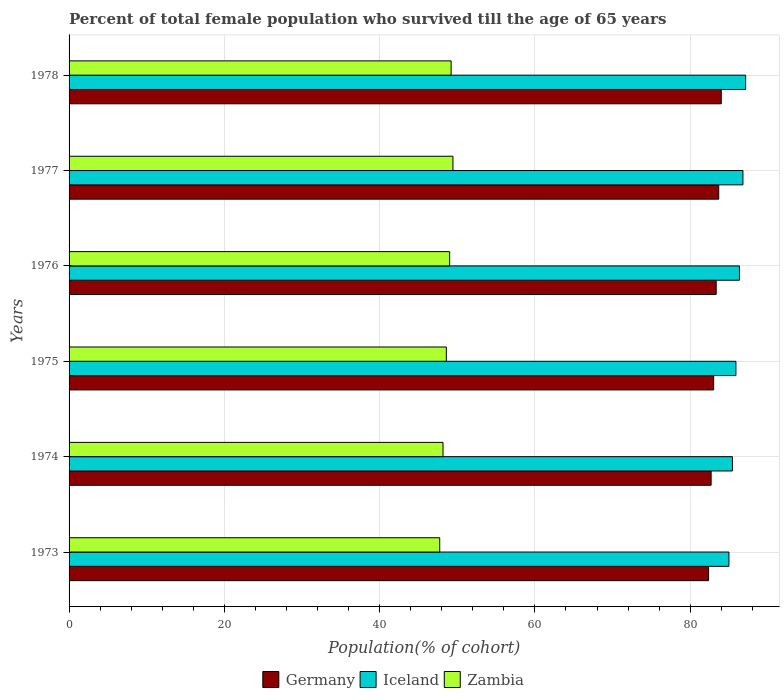How many groups of bars are there?
Offer a very short reply. 6. Are the number of bars per tick equal to the number of legend labels?
Your answer should be compact. Yes. How many bars are there on the 5th tick from the top?
Offer a terse response. 3. What is the label of the 2nd group of bars from the top?
Provide a succinct answer. 1977. What is the percentage of total female population who survived till the age of 65 years in Germany in 1978?
Your answer should be compact. 84. Across all years, what is the maximum percentage of total female population who survived till the age of 65 years in Germany?
Give a very brief answer. 84. Across all years, what is the minimum percentage of total female population who survived till the age of 65 years in Iceland?
Your response must be concise. 84.99. In which year was the percentage of total female population who survived till the age of 65 years in Germany maximum?
Provide a short and direct response. 1978. In which year was the percentage of total female population who survived till the age of 65 years in Germany minimum?
Your response must be concise. 1973. What is the total percentage of total female population who survived till the age of 65 years in Germany in the graph?
Make the answer very short. 499.11. What is the difference between the percentage of total female population who survived till the age of 65 years in Zambia in 1973 and that in 1974?
Provide a succinct answer. -0.43. What is the difference between the percentage of total female population who survived till the age of 65 years in Iceland in 1978 and the percentage of total female population who survived till the age of 65 years in Zambia in 1977?
Ensure brevity in your answer.  37.7. What is the average percentage of total female population who survived till the age of 65 years in Germany per year?
Keep it short and to the point. 83.19. In the year 1974, what is the difference between the percentage of total female population who survived till the age of 65 years in Zambia and percentage of total female population who survived till the age of 65 years in Germany?
Ensure brevity in your answer.  -34.53. In how many years, is the percentage of total female population who survived till the age of 65 years in Iceland greater than 76 %?
Your answer should be very brief. 6. What is the ratio of the percentage of total female population who survived till the age of 65 years in Zambia in 1975 to that in 1976?
Provide a short and direct response. 0.99. Is the percentage of total female population who survived till the age of 65 years in Iceland in 1973 less than that in 1976?
Offer a terse response. Yes. Is the difference between the percentage of total female population who survived till the age of 65 years in Zambia in 1974 and 1978 greater than the difference between the percentage of total female population who survived till the age of 65 years in Germany in 1974 and 1978?
Offer a very short reply. Yes. What is the difference between the highest and the second highest percentage of total female population who survived till the age of 65 years in Zambia?
Your answer should be compact. 0.23. What is the difference between the highest and the lowest percentage of total female population who survived till the age of 65 years in Zambia?
Give a very brief answer. 1.7. In how many years, is the percentage of total female population who survived till the age of 65 years in Germany greater than the average percentage of total female population who survived till the age of 65 years in Germany taken over all years?
Your answer should be very brief. 3. Is the sum of the percentage of total female population who survived till the age of 65 years in Iceland in 1976 and 1978 greater than the maximum percentage of total female population who survived till the age of 65 years in Germany across all years?
Provide a short and direct response. Yes. What does the 2nd bar from the bottom in 1976 represents?
Provide a short and direct response. Iceland. Are the values on the major ticks of X-axis written in scientific E-notation?
Ensure brevity in your answer.  No. Does the graph contain any zero values?
Keep it short and to the point. No. Does the graph contain grids?
Your response must be concise. Yes. Where does the legend appear in the graph?
Your answer should be compact. Bottom center. How many legend labels are there?
Give a very brief answer. 3. How are the legend labels stacked?
Offer a very short reply. Horizontal. What is the title of the graph?
Make the answer very short. Percent of total female population who survived till the age of 65 years. Does "Bhutan" appear as one of the legend labels in the graph?
Ensure brevity in your answer.  No. What is the label or title of the X-axis?
Make the answer very short. Population(% of cohort). What is the Population(% of cohort) of Germany in 1973?
Ensure brevity in your answer.  82.37. What is the Population(% of cohort) in Iceland in 1973?
Keep it short and to the point. 84.99. What is the Population(% of cohort) of Zambia in 1973?
Your answer should be very brief. 47.74. What is the Population(% of cohort) in Germany in 1974?
Your answer should be compact. 82.7. What is the Population(% of cohort) in Iceland in 1974?
Make the answer very short. 85.44. What is the Population(% of cohort) of Zambia in 1974?
Ensure brevity in your answer.  48.17. What is the Population(% of cohort) of Germany in 1975?
Give a very brief answer. 83.02. What is the Population(% of cohort) of Iceland in 1975?
Give a very brief answer. 85.89. What is the Population(% of cohort) of Zambia in 1975?
Your answer should be compact. 48.59. What is the Population(% of cohort) in Germany in 1976?
Give a very brief answer. 83.35. What is the Population(% of cohort) of Iceland in 1976?
Your response must be concise. 86.34. What is the Population(% of cohort) in Zambia in 1976?
Give a very brief answer. 49.02. What is the Population(% of cohort) of Germany in 1977?
Your answer should be very brief. 83.67. What is the Population(% of cohort) in Iceland in 1977?
Make the answer very short. 86.79. What is the Population(% of cohort) in Zambia in 1977?
Keep it short and to the point. 49.44. What is the Population(% of cohort) of Germany in 1978?
Make the answer very short. 84. What is the Population(% of cohort) in Iceland in 1978?
Provide a succinct answer. 87.15. What is the Population(% of cohort) in Zambia in 1978?
Provide a succinct answer. 49.21. Across all years, what is the maximum Population(% of cohort) in Germany?
Offer a very short reply. 84. Across all years, what is the maximum Population(% of cohort) in Iceland?
Your response must be concise. 87.15. Across all years, what is the maximum Population(% of cohort) in Zambia?
Give a very brief answer. 49.44. Across all years, what is the minimum Population(% of cohort) of Germany?
Offer a terse response. 82.37. Across all years, what is the minimum Population(% of cohort) of Iceland?
Your response must be concise. 84.99. Across all years, what is the minimum Population(% of cohort) of Zambia?
Offer a very short reply. 47.74. What is the total Population(% of cohort) of Germany in the graph?
Ensure brevity in your answer.  499.11. What is the total Population(% of cohort) of Iceland in the graph?
Your answer should be very brief. 516.6. What is the total Population(% of cohort) in Zambia in the graph?
Offer a terse response. 292.16. What is the difference between the Population(% of cohort) of Germany in 1973 and that in 1974?
Ensure brevity in your answer.  -0.33. What is the difference between the Population(% of cohort) in Iceland in 1973 and that in 1974?
Your response must be concise. -0.45. What is the difference between the Population(% of cohort) in Zambia in 1973 and that in 1974?
Provide a succinct answer. -0.43. What is the difference between the Population(% of cohort) in Germany in 1973 and that in 1975?
Provide a succinct answer. -0.65. What is the difference between the Population(% of cohort) in Iceland in 1973 and that in 1975?
Provide a succinct answer. -0.9. What is the difference between the Population(% of cohort) of Zambia in 1973 and that in 1975?
Your answer should be compact. -0.85. What is the difference between the Population(% of cohort) in Germany in 1973 and that in 1976?
Your answer should be compact. -0.98. What is the difference between the Population(% of cohort) in Iceland in 1973 and that in 1976?
Your response must be concise. -1.35. What is the difference between the Population(% of cohort) in Zambia in 1973 and that in 1976?
Keep it short and to the point. -1.28. What is the difference between the Population(% of cohort) of Germany in 1973 and that in 1977?
Offer a terse response. -1.3. What is the difference between the Population(% of cohort) of Iceland in 1973 and that in 1977?
Provide a succinct answer. -1.8. What is the difference between the Population(% of cohort) of Zambia in 1973 and that in 1977?
Make the answer very short. -1.7. What is the difference between the Population(% of cohort) of Germany in 1973 and that in 1978?
Provide a succinct answer. -1.63. What is the difference between the Population(% of cohort) of Iceland in 1973 and that in 1978?
Provide a short and direct response. -2.16. What is the difference between the Population(% of cohort) in Zambia in 1973 and that in 1978?
Keep it short and to the point. -1.47. What is the difference between the Population(% of cohort) of Germany in 1974 and that in 1975?
Your answer should be very brief. -0.33. What is the difference between the Population(% of cohort) of Iceland in 1974 and that in 1975?
Provide a succinct answer. -0.45. What is the difference between the Population(% of cohort) in Zambia in 1974 and that in 1975?
Ensure brevity in your answer.  -0.43. What is the difference between the Population(% of cohort) of Germany in 1974 and that in 1976?
Your answer should be very brief. -0.65. What is the difference between the Population(% of cohort) of Iceland in 1974 and that in 1976?
Your answer should be compact. -0.9. What is the difference between the Population(% of cohort) in Zambia in 1974 and that in 1976?
Provide a succinct answer. -0.85. What is the difference between the Population(% of cohort) of Germany in 1974 and that in 1977?
Your answer should be very brief. -0.98. What is the difference between the Population(% of cohort) of Iceland in 1974 and that in 1977?
Your answer should be very brief. -1.35. What is the difference between the Population(% of cohort) in Zambia in 1974 and that in 1977?
Your response must be concise. -1.28. What is the difference between the Population(% of cohort) of Germany in 1974 and that in 1978?
Give a very brief answer. -1.31. What is the difference between the Population(% of cohort) in Iceland in 1974 and that in 1978?
Your response must be concise. -1.71. What is the difference between the Population(% of cohort) of Zambia in 1974 and that in 1978?
Your answer should be compact. -1.04. What is the difference between the Population(% of cohort) in Germany in 1975 and that in 1976?
Your response must be concise. -0.33. What is the difference between the Population(% of cohort) of Iceland in 1975 and that in 1976?
Provide a succinct answer. -0.45. What is the difference between the Population(% of cohort) in Zambia in 1975 and that in 1976?
Offer a very short reply. -0.43. What is the difference between the Population(% of cohort) in Germany in 1975 and that in 1977?
Your answer should be very brief. -0.65. What is the difference between the Population(% of cohort) of Iceland in 1975 and that in 1977?
Your response must be concise. -0.9. What is the difference between the Population(% of cohort) of Zambia in 1975 and that in 1977?
Ensure brevity in your answer.  -0.85. What is the difference between the Population(% of cohort) in Germany in 1975 and that in 1978?
Give a very brief answer. -0.98. What is the difference between the Population(% of cohort) of Iceland in 1975 and that in 1978?
Your answer should be very brief. -1.25. What is the difference between the Population(% of cohort) in Zambia in 1975 and that in 1978?
Offer a very short reply. -0.62. What is the difference between the Population(% of cohort) of Germany in 1976 and that in 1977?
Offer a terse response. -0.33. What is the difference between the Population(% of cohort) in Iceland in 1976 and that in 1977?
Your answer should be very brief. -0.45. What is the difference between the Population(% of cohort) of Zambia in 1976 and that in 1977?
Give a very brief answer. -0.43. What is the difference between the Population(% of cohort) of Germany in 1976 and that in 1978?
Provide a succinct answer. -0.65. What is the difference between the Population(% of cohort) of Iceland in 1976 and that in 1978?
Your response must be concise. -0.8. What is the difference between the Population(% of cohort) in Zambia in 1976 and that in 1978?
Give a very brief answer. -0.19. What is the difference between the Population(% of cohort) in Germany in 1977 and that in 1978?
Your response must be concise. -0.33. What is the difference between the Population(% of cohort) in Iceland in 1977 and that in 1978?
Your answer should be compact. -0.35. What is the difference between the Population(% of cohort) in Zambia in 1977 and that in 1978?
Your answer should be compact. 0.23. What is the difference between the Population(% of cohort) of Germany in 1973 and the Population(% of cohort) of Iceland in 1974?
Offer a very short reply. -3.07. What is the difference between the Population(% of cohort) in Germany in 1973 and the Population(% of cohort) in Zambia in 1974?
Offer a terse response. 34.2. What is the difference between the Population(% of cohort) in Iceland in 1973 and the Population(% of cohort) in Zambia in 1974?
Offer a very short reply. 36.82. What is the difference between the Population(% of cohort) of Germany in 1973 and the Population(% of cohort) of Iceland in 1975?
Offer a terse response. -3.52. What is the difference between the Population(% of cohort) of Germany in 1973 and the Population(% of cohort) of Zambia in 1975?
Provide a succinct answer. 33.78. What is the difference between the Population(% of cohort) of Iceland in 1973 and the Population(% of cohort) of Zambia in 1975?
Offer a terse response. 36.4. What is the difference between the Population(% of cohort) in Germany in 1973 and the Population(% of cohort) in Iceland in 1976?
Provide a succinct answer. -3.97. What is the difference between the Population(% of cohort) in Germany in 1973 and the Population(% of cohort) in Zambia in 1976?
Offer a terse response. 33.35. What is the difference between the Population(% of cohort) in Iceland in 1973 and the Population(% of cohort) in Zambia in 1976?
Give a very brief answer. 35.97. What is the difference between the Population(% of cohort) of Germany in 1973 and the Population(% of cohort) of Iceland in 1977?
Provide a short and direct response. -4.42. What is the difference between the Population(% of cohort) of Germany in 1973 and the Population(% of cohort) of Zambia in 1977?
Ensure brevity in your answer.  32.93. What is the difference between the Population(% of cohort) of Iceland in 1973 and the Population(% of cohort) of Zambia in 1977?
Provide a succinct answer. 35.55. What is the difference between the Population(% of cohort) in Germany in 1973 and the Population(% of cohort) in Iceland in 1978?
Your response must be concise. -4.78. What is the difference between the Population(% of cohort) in Germany in 1973 and the Population(% of cohort) in Zambia in 1978?
Provide a short and direct response. 33.16. What is the difference between the Population(% of cohort) of Iceland in 1973 and the Population(% of cohort) of Zambia in 1978?
Ensure brevity in your answer.  35.78. What is the difference between the Population(% of cohort) in Germany in 1974 and the Population(% of cohort) in Iceland in 1975?
Make the answer very short. -3.2. What is the difference between the Population(% of cohort) of Germany in 1974 and the Population(% of cohort) of Zambia in 1975?
Your answer should be compact. 34.11. What is the difference between the Population(% of cohort) in Iceland in 1974 and the Population(% of cohort) in Zambia in 1975?
Provide a succinct answer. 36.85. What is the difference between the Population(% of cohort) of Germany in 1974 and the Population(% of cohort) of Iceland in 1976?
Ensure brevity in your answer.  -3.65. What is the difference between the Population(% of cohort) of Germany in 1974 and the Population(% of cohort) of Zambia in 1976?
Offer a very short reply. 33.68. What is the difference between the Population(% of cohort) in Iceland in 1974 and the Population(% of cohort) in Zambia in 1976?
Offer a terse response. 36.42. What is the difference between the Population(% of cohort) of Germany in 1974 and the Population(% of cohort) of Iceland in 1977?
Ensure brevity in your answer.  -4.1. What is the difference between the Population(% of cohort) in Germany in 1974 and the Population(% of cohort) in Zambia in 1977?
Provide a short and direct response. 33.25. What is the difference between the Population(% of cohort) of Iceland in 1974 and the Population(% of cohort) of Zambia in 1977?
Offer a terse response. 36. What is the difference between the Population(% of cohort) in Germany in 1974 and the Population(% of cohort) in Iceland in 1978?
Offer a very short reply. -4.45. What is the difference between the Population(% of cohort) of Germany in 1974 and the Population(% of cohort) of Zambia in 1978?
Keep it short and to the point. 33.49. What is the difference between the Population(% of cohort) of Iceland in 1974 and the Population(% of cohort) of Zambia in 1978?
Your answer should be compact. 36.23. What is the difference between the Population(% of cohort) of Germany in 1975 and the Population(% of cohort) of Iceland in 1976?
Your answer should be very brief. -3.32. What is the difference between the Population(% of cohort) in Germany in 1975 and the Population(% of cohort) in Zambia in 1976?
Make the answer very short. 34.01. What is the difference between the Population(% of cohort) in Iceland in 1975 and the Population(% of cohort) in Zambia in 1976?
Make the answer very short. 36.87. What is the difference between the Population(% of cohort) in Germany in 1975 and the Population(% of cohort) in Iceland in 1977?
Make the answer very short. -3.77. What is the difference between the Population(% of cohort) in Germany in 1975 and the Population(% of cohort) in Zambia in 1977?
Ensure brevity in your answer.  33.58. What is the difference between the Population(% of cohort) of Iceland in 1975 and the Population(% of cohort) of Zambia in 1977?
Your answer should be very brief. 36.45. What is the difference between the Population(% of cohort) in Germany in 1975 and the Population(% of cohort) in Iceland in 1978?
Your response must be concise. -4.12. What is the difference between the Population(% of cohort) in Germany in 1975 and the Population(% of cohort) in Zambia in 1978?
Ensure brevity in your answer.  33.81. What is the difference between the Population(% of cohort) of Iceland in 1975 and the Population(% of cohort) of Zambia in 1978?
Give a very brief answer. 36.68. What is the difference between the Population(% of cohort) in Germany in 1976 and the Population(% of cohort) in Iceland in 1977?
Your answer should be compact. -3.45. What is the difference between the Population(% of cohort) of Germany in 1976 and the Population(% of cohort) of Zambia in 1977?
Your answer should be compact. 33.91. What is the difference between the Population(% of cohort) of Iceland in 1976 and the Population(% of cohort) of Zambia in 1977?
Offer a terse response. 36.9. What is the difference between the Population(% of cohort) of Germany in 1976 and the Population(% of cohort) of Iceland in 1978?
Keep it short and to the point. -3.8. What is the difference between the Population(% of cohort) in Germany in 1976 and the Population(% of cohort) in Zambia in 1978?
Provide a succinct answer. 34.14. What is the difference between the Population(% of cohort) of Iceland in 1976 and the Population(% of cohort) of Zambia in 1978?
Provide a succinct answer. 37.13. What is the difference between the Population(% of cohort) of Germany in 1977 and the Population(% of cohort) of Iceland in 1978?
Your answer should be very brief. -3.47. What is the difference between the Population(% of cohort) of Germany in 1977 and the Population(% of cohort) of Zambia in 1978?
Offer a very short reply. 34.47. What is the difference between the Population(% of cohort) in Iceland in 1977 and the Population(% of cohort) in Zambia in 1978?
Offer a very short reply. 37.58. What is the average Population(% of cohort) of Germany per year?
Give a very brief answer. 83.19. What is the average Population(% of cohort) in Iceland per year?
Give a very brief answer. 86.1. What is the average Population(% of cohort) in Zambia per year?
Make the answer very short. 48.69. In the year 1973, what is the difference between the Population(% of cohort) in Germany and Population(% of cohort) in Iceland?
Your response must be concise. -2.62. In the year 1973, what is the difference between the Population(% of cohort) in Germany and Population(% of cohort) in Zambia?
Give a very brief answer. 34.63. In the year 1973, what is the difference between the Population(% of cohort) in Iceland and Population(% of cohort) in Zambia?
Ensure brevity in your answer.  37.25. In the year 1974, what is the difference between the Population(% of cohort) of Germany and Population(% of cohort) of Iceland?
Provide a short and direct response. -2.74. In the year 1974, what is the difference between the Population(% of cohort) in Germany and Population(% of cohort) in Zambia?
Make the answer very short. 34.53. In the year 1974, what is the difference between the Population(% of cohort) of Iceland and Population(% of cohort) of Zambia?
Make the answer very short. 37.28. In the year 1975, what is the difference between the Population(% of cohort) of Germany and Population(% of cohort) of Iceland?
Provide a short and direct response. -2.87. In the year 1975, what is the difference between the Population(% of cohort) of Germany and Population(% of cohort) of Zambia?
Keep it short and to the point. 34.43. In the year 1975, what is the difference between the Population(% of cohort) of Iceland and Population(% of cohort) of Zambia?
Your answer should be compact. 37.3. In the year 1976, what is the difference between the Population(% of cohort) in Germany and Population(% of cohort) in Iceland?
Offer a very short reply. -2.99. In the year 1976, what is the difference between the Population(% of cohort) in Germany and Population(% of cohort) in Zambia?
Ensure brevity in your answer.  34.33. In the year 1976, what is the difference between the Population(% of cohort) of Iceland and Population(% of cohort) of Zambia?
Your response must be concise. 37.33. In the year 1977, what is the difference between the Population(% of cohort) of Germany and Population(% of cohort) of Iceland?
Offer a very short reply. -3.12. In the year 1977, what is the difference between the Population(% of cohort) in Germany and Population(% of cohort) in Zambia?
Provide a short and direct response. 34.23. In the year 1977, what is the difference between the Population(% of cohort) of Iceland and Population(% of cohort) of Zambia?
Provide a succinct answer. 37.35. In the year 1978, what is the difference between the Population(% of cohort) of Germany and Population(% of cohort) of Iceland?
Your answer should be compact. -3.14. In the year 1978, what is the difference between the Population(% of cohort) in Germany and Population(% of cohort) in Zambia?
Your response must be concise. 34.79. In the year 1978, what is the difference between the Population(% of cohort) of Iceland and Population(% of cohort) of Zambia?
Keep it short and to the point. 37.94. What is the ratio of the Population(% of cohort) of Germany in 1973 to that in 1975?
Offer a very short reply. 0.99. What is the ratio of the Population(% of cohort) of Iceland in 1973 to that in 1975?
Keep it short and to the point. 0.99. What is the ratio of the Population(% of cohort) in Zambia in 1973 to that in 1975?
Give a very brief answer. 0.98. What is the ratio of the Population(% of cohort) in Germany in 1973 to that in 1976?
Make the answer very short. 0.99. What is the ratio of the Population(% of cohort) in Iceland in 1973 to that in 1976?
Provide a succinct answer. 0.98. What is the ratio of the Population(% of cohort) of Zambia in 1973 to that in 1976?
Keep it short and to the point. 0.97. What is the ratio of the Population(% of cohort) of Germany in 1973 to that in 1977?
Give a very brief answer. 0.98. What is the ratio of the Population(% of cohort) of Iceland in 1973 to that in 1977?
Ensure brevity in your answer.  0.98. What is the ratio of the Population(% of cohort) in Zambia in 1973 to that in 1977?
Give a very brief answer. 0.97. What is the ratio of the Population(% of cohort) of Germany in 1973 to that in 1978?
Keep it short and to the point. 0.98. What is the ratio of the Population(% of cohort) of Iceland in 1973 to that in 1978?
Provide a succinct answer. 0.98. What is the ratio of the Population(% of cohort) in Zambia in 1973 to that in 1978?
Your answer should be very brief. 0.97. What is the ratio of the Population(% of cohort) of Iceland in 1974 to that in 1975?
Provide a succinct answer. 0.99. What is the ratio of the Population(% of cohort) of Zambia in 1974 to that in 1975?
Provide a short and direct response. 0.99. What is the ratio of the Population(% of cohort) in Germany in 1974 to that in 1976?
Your answer should be compact. 0.99. What is the ratio of the Population(% of cohort) of Iceland in 1974 to that in 1976?
Your answer should be very brief. 0.99. What is the ratio of the Population(% of cohort) in Zambia in 1974 to that in 1976?
Ensure brevity in your answer.  0.98. What is the ratio of the Population(% of cohort) in Germany in 1974 to that in 1977?
Provide a succinct answer. 0.99. What is the ratio of the Population(% of cohort) of Iceland in 1974 to that in 1977?
Give a very brief answer. 0.98. What is the ratio of the Population(% of cohort) in Zambia in 1974 to that in 1977?
Make the answer very short. 0.97. What is the ratio of the Population(% of cohort) in Germany in 1974 to that in 1978?
Your answer should be compact. 0.98. What is the ratio of the Population(% of cohort) of Iceland in 1974 to that in 1978?
Offer a very short reply. 0.98. What is the ratio of the Population(% of cohort) of Zambia in 1974 to that in 1978?
Ensure brevity in your answer.  0.98. What is the ratio of the Population(% of cohort) in Germany in 1975 to that in 1976?
Ensure brevity in your answer.  1. What is the ratio of the Population(% of cohort) in Iceland in 1975 to that in 1976?
Provide a short and direct response. 0.99. What is the ratio of the Population(% of cohort) of Zambia in 1975 to that in 1976?
Provide a short and direct response. 0.99. What is the ratio of the Population(% of cohort) in Zambia in 1975 to that in 1977?
Your answer should be very brief. 0.98. What is the ratio of the Population(% of cohort) in Germany in 1975 to that in 1978?
Your response must be concise. 0.99. What is the ratio of the Population(% of cohort) in Iceland in 1975 to that in 1978?
Your answer should be compact. 0.99. What is the ratio of the Population(% of cohort) of Zambia in 1975 to that in 1978?
Offer a very short reply. 0.99. What is the ratio of the Population(% of cohort) in Germany in 1976 to that in 1977?
Provide a short and direct response. 1. What is the ratio of the Population(% of cohort) in Iceland in 1976 to that in 1977?
Offer a very short reply. 0.99. What is the ratio of the Population(% of cohort) in Iceland in 1976 to that in 1978?
Offer a very short reply. 0.99. What is the ratio of the Population(% of cohort) in Zambia in 1976 to that in 1978?
Offer a very short reply. 1. What is the ratio of the Population(% of cohort) in Iceland in 1977 to that in 1978?
Make the answer very short. 1. What is the difference between the highest and the second highest Population(% of cohort) in Germany?
Make the answer very short. 0.33. What is the difference between the highest and the second highest Population(% of cohort) of Iceland?
Make the answer very short. 0.35. What is the difference between the highest and the second highest Population(% of cohort) of Zambia?
Your response must be concise. 0.23. What is the difference between the highest and the lowest Population(% of cohort) in Germany?
Give a very brief answer. 1.63. What is the difference between the highest and the lowest Population(% of cohort) of Iceland?
Provide a succinct answer. 2.16. What is the difference between the highest and the lowest Population(% of cohort) of Zambia?
Provide a short and direct response. 1.7. 